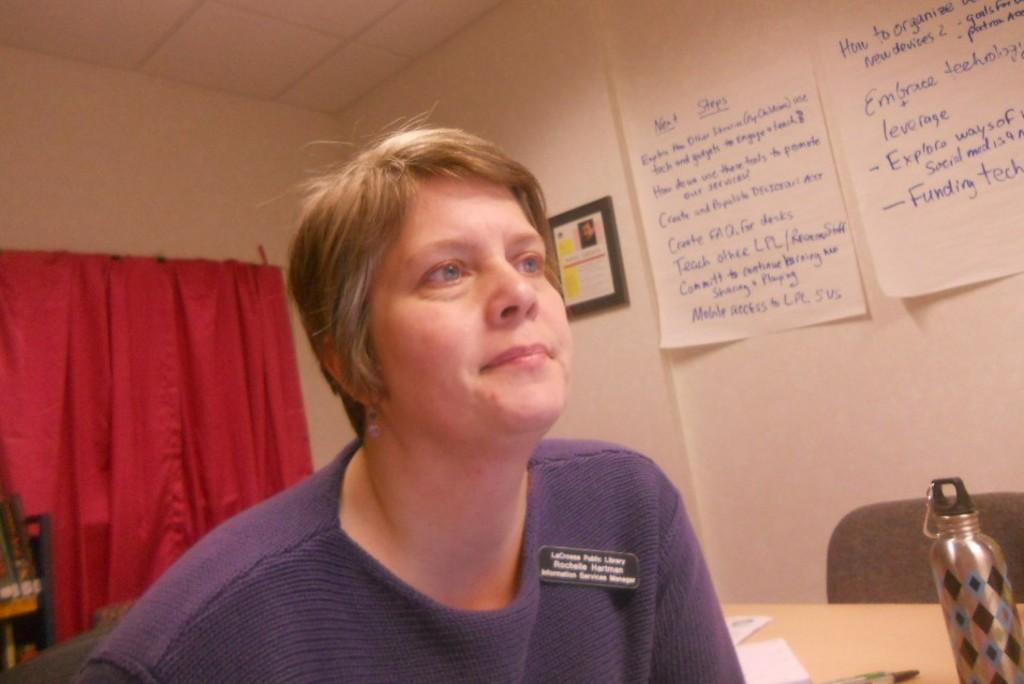In one or two sentences, can you explain what this image depicts? A woman is looking at the right side, she wore a sweater. On the left side there is a curtain. There is a water bottle on the table. 